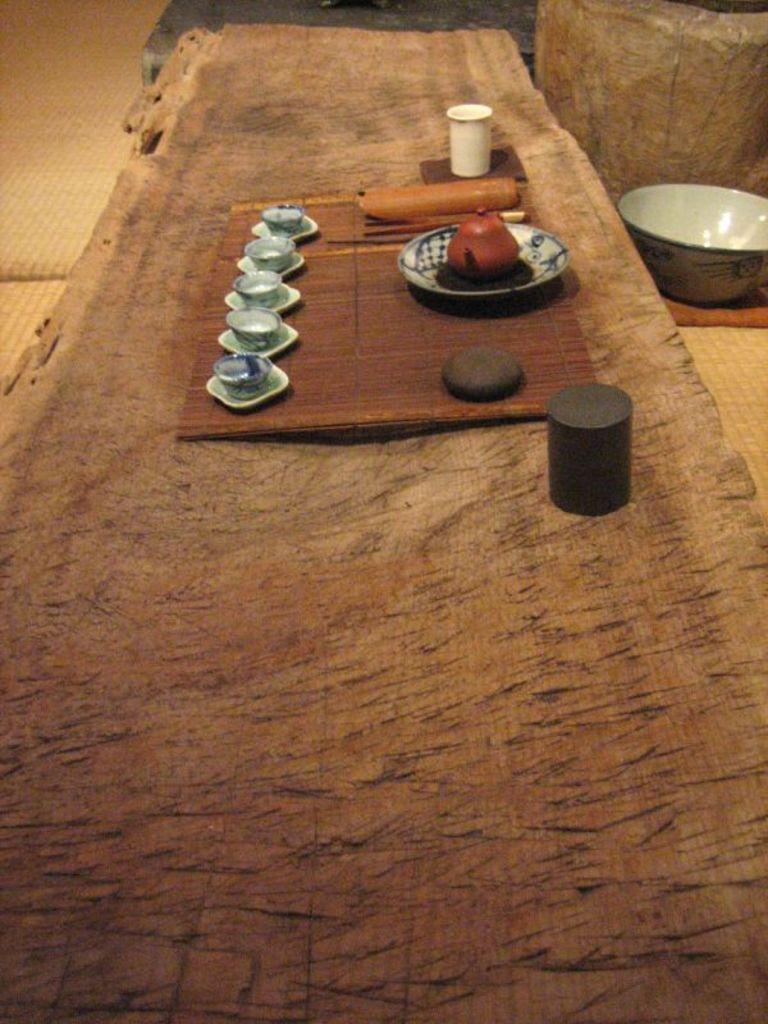Can you describe this image briefly? In this picture we can observe five porcelain cups placed on the wooden surface. We can observe a plate and a glass on the surface. On the right side there is a bowl. 